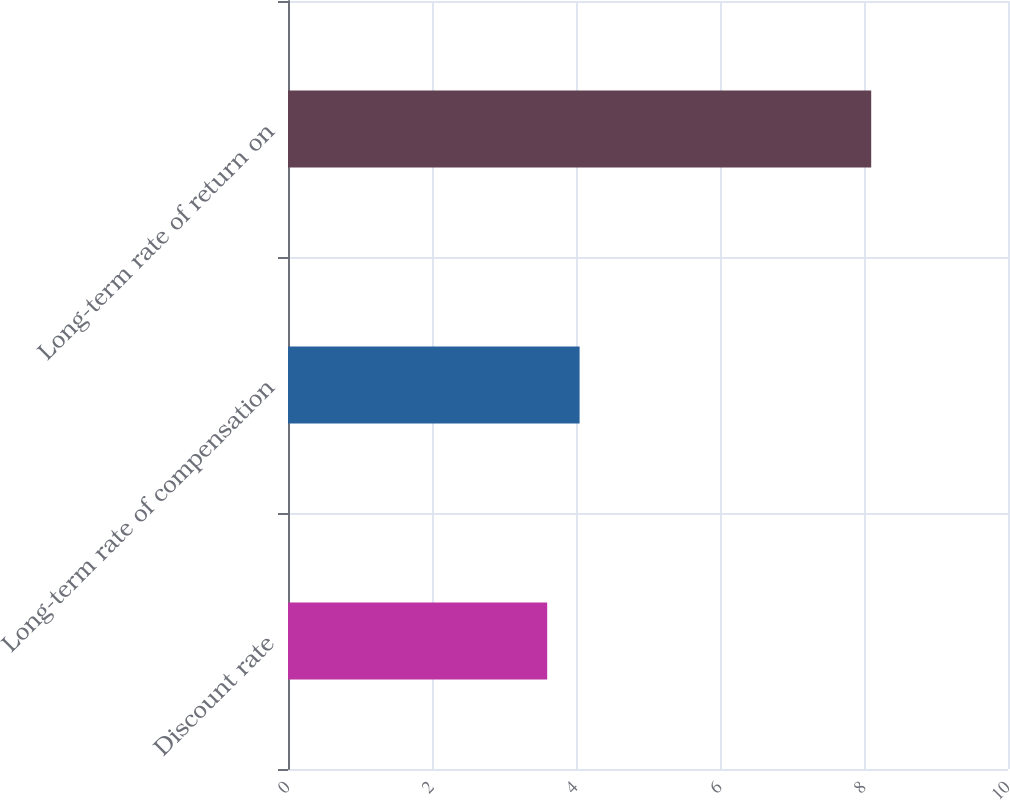Convert chart to OTSL. <chart><loc_0><loc_0><loc_500><loc_500><bar_chart><fcel>Discount rate<fcel>Long-term rate of compensation<fcel>Long-term rate of return on<nl><fcel>3.6<fcel>4.05<fcel>8.1<nl></chart> 